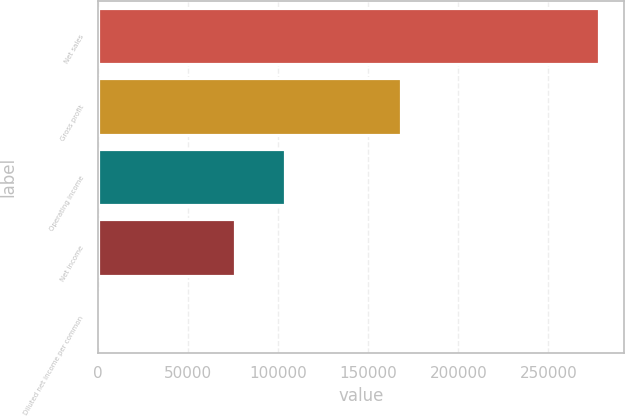<chart> <loc_0><loc_0><loc_500><loc_500><bar_chart><fcel>Net sales<fcel>Gross profit<fcel>Operating income<fcel>Net income<fcel>Diluted net income per common<nl><fcel>278020<fcel>168471<fcel>103551<fcel>75749<fcel>0.4<nl></chart> 